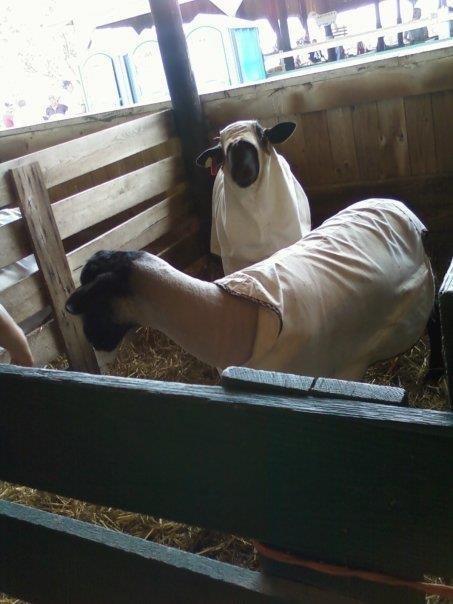Wool in People's clothing?
Answer briefly. Yes. Are the sheep wearing jackets?
Short answer required. Yes. Do they wear jackets for cold weather?
Short answer required. Yes. 